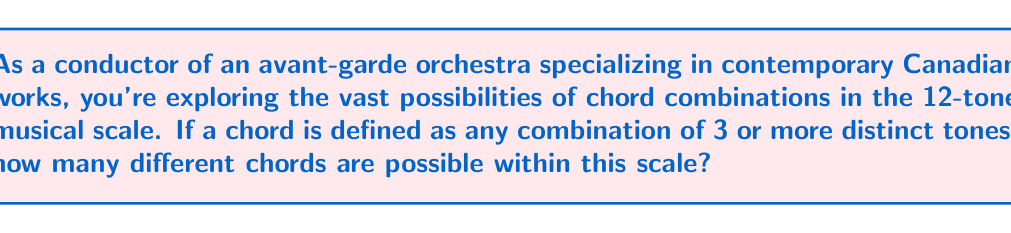Show me your answer to this math problem. Let's approach this step-by-step:

1) In a 12-tone scale, we have 12 distinct tones to choose from.

2) We need to calculate the number of combinations for chords with 3, 4, 5, ..., up to 12 tones.

3) For each of these, we use the combination formula:

   $$C(n,r) = \frac{n!}{r!(n-r)!}$$

   where $n = 12$ (total number of tones) and $r$ is the number of tones in the chord.

4) Let's calculate each:
   
   For 3-tone chords: $C(12,3) = \frac{12!}{3!(12-3)!} = 220$
   For 4-tone chords: $C(12,4) = \frac{12!}{4!(12-4)!} = 495$
   For 5-tone chords: $C(12,5) = \frac{12!}{5!(12-5)!} = 792$
   For 6-tone chords: $C(12,6) = \frac{12!}{6!(12-6)!} = 924$
   For 7-tone chords: $C(12,7) = \frac{12!}{7!(12-7)!} = 792$
   For 8-tone chords: $C(12,8) = \frac{12!}{8!(12-8)!} = 495$
   For 9-tone chords: $C(12,9) = \frac{12!}{9!(12-9)!} = 220$
   For 10-tone chords: $C(12,10) = \frac{12!}{10!(12-10)!} = 66$
   For 11-tone chords: $C(12,11) = \frac{12!}{11!(12-11)!} = 12$
   For 12-tone chord: $C(12,12) = \frac{12!}{12!(12-12)!} = 1$

5) To get the total number of possible chords, we sum all these values:

   $$220 + 495 + 792 + 924 + 792 + 495 + 220 + 66 + 12 + 1 = 4017$$

Therefore, there are 4017 possible chord combinations in a 12-tone musical scale.
Answer: 4017 